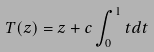<formula> <loc_0><loc_0><loc_500><loc_500>T ( z ) = z + c \int _ { 0 } ^ { 1 } t d t</formula> 